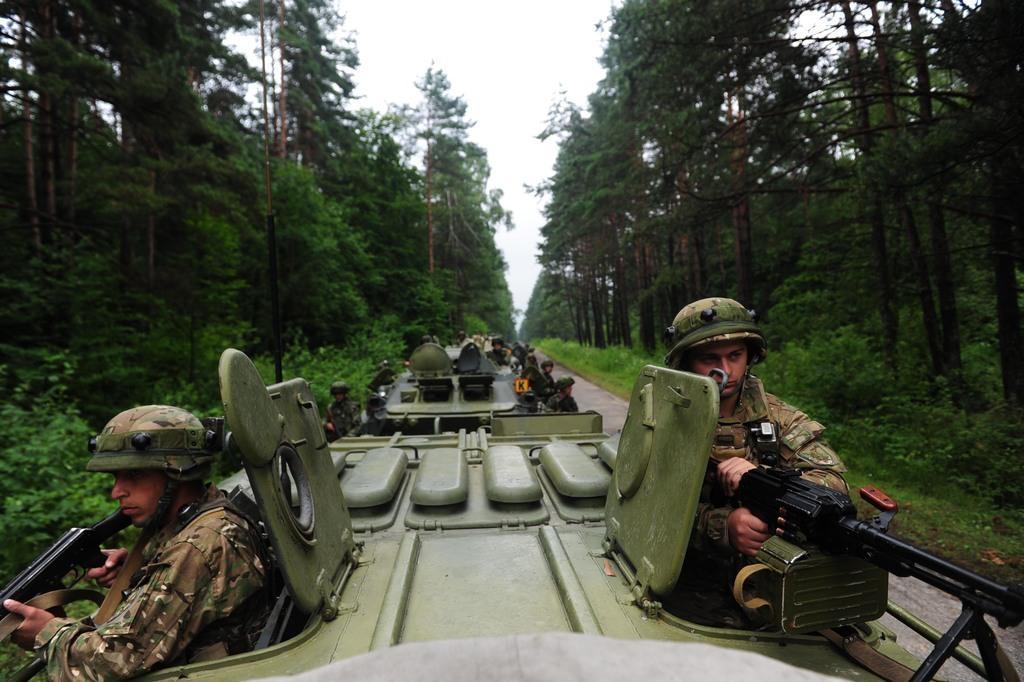Can you describe this image briefly? This picture is taken from the outside of the city. In this image, in the middle, we can see a vehicle, in the vehicle, we can see a group of people holding weapons in their hand. On the right side, we can see some trees and plants. On the left side, we can see some trees and plants. At the top, we can see a sky, at the bottom, we can see a grass and a road. 